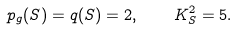Convert formula to latex. <formula><loc_0><loc_0><loc_500><loc_500>p _ { g } ( S ) = q ( S ) = 2 , \quad K _ { S } ^ { 2 } = 5 .</formula> 